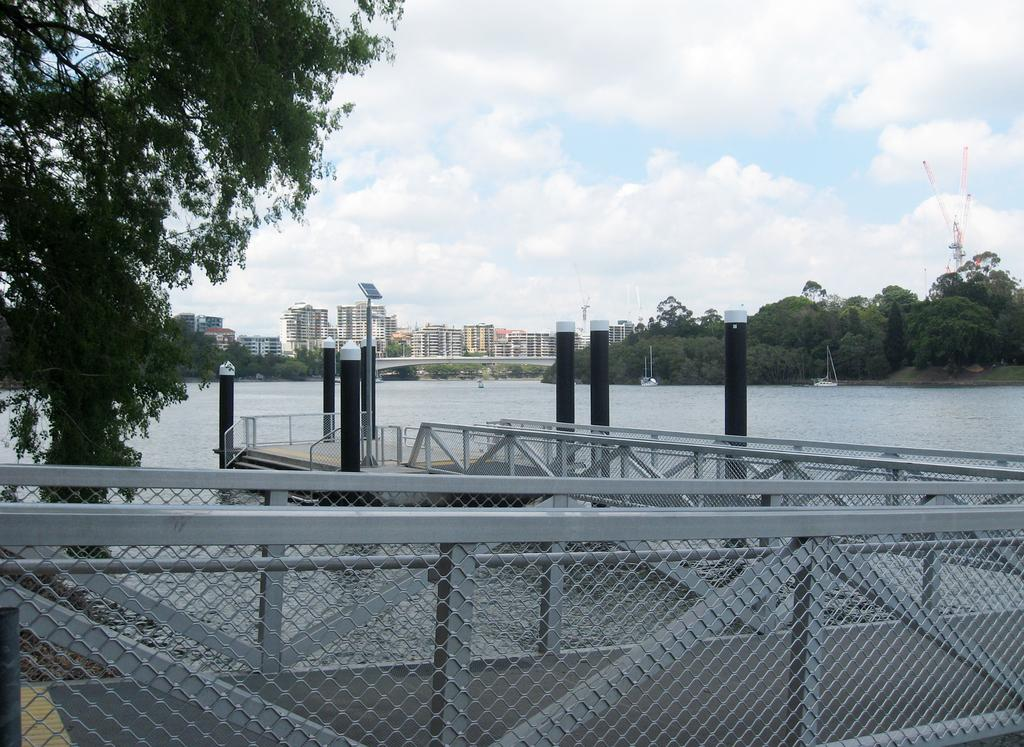What type of structures can be seen in the image? There are buildings and towers in the image. What natural elements are present in the image? There are trees in the image. What is in the water in the image? There are boats in the water in the image. How can people cross the water in the image? There is a foot over bridge in the image. What is the condition of the sky in the image? The sky is blue and cloudy in the image. Can you tell me how many calculators are visible on the foot over bridge in the image? There are no calculators present in the image; it features buildings, trees, boats, towers, and a foot over bridge. What type of silk is draped over the trees in the image? There is no silk draped over the trees in the image; only trees, buildings, towers, boats, and a foot over bridge are present. 